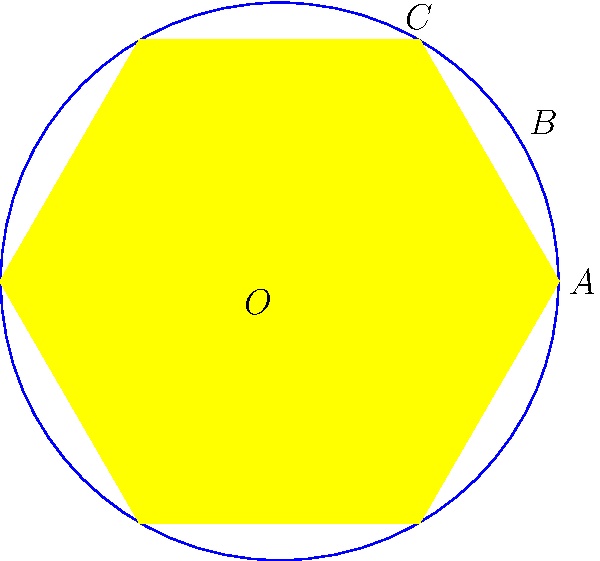The flag of the European Union features 12 golden stars arranged in a circle on a blue background. In this simplified representation, points A, B, and C are three consecutive star points on the circle, and O is the center. If the central angle AOC measures 60°, what is the measure of angle ABC? Let's approach this step-by-step:

1) First, we need to understand the geometry of the EU flag. It has 12 stars equally spaced around a circle.

2) The central angle between any two adjacent stars is:
   $$\frac{360°}{12} = 30°$$

3) We're given that angle AOC is 60°. This means it spans two star intervals.

4) In a circle, an inscribed angle is half the measure of the central angle that subtends the same arc. This is a fundamental theorem in circle geometry.

5) Angle ABC is an inscribed angle that subtends the same arc as the central angle AOC.

6) Therefore, the measure of angle ABC is half of angle AOC:
   $$\angle ABC = \frac{1}{2} \angle AOC = \frac{1}{2} \cdot 60° = 30°$$

This result aligns with the historical and political symbolism of the EU flag, where each star is equal and the circle represents unity.
Answer: 30° 